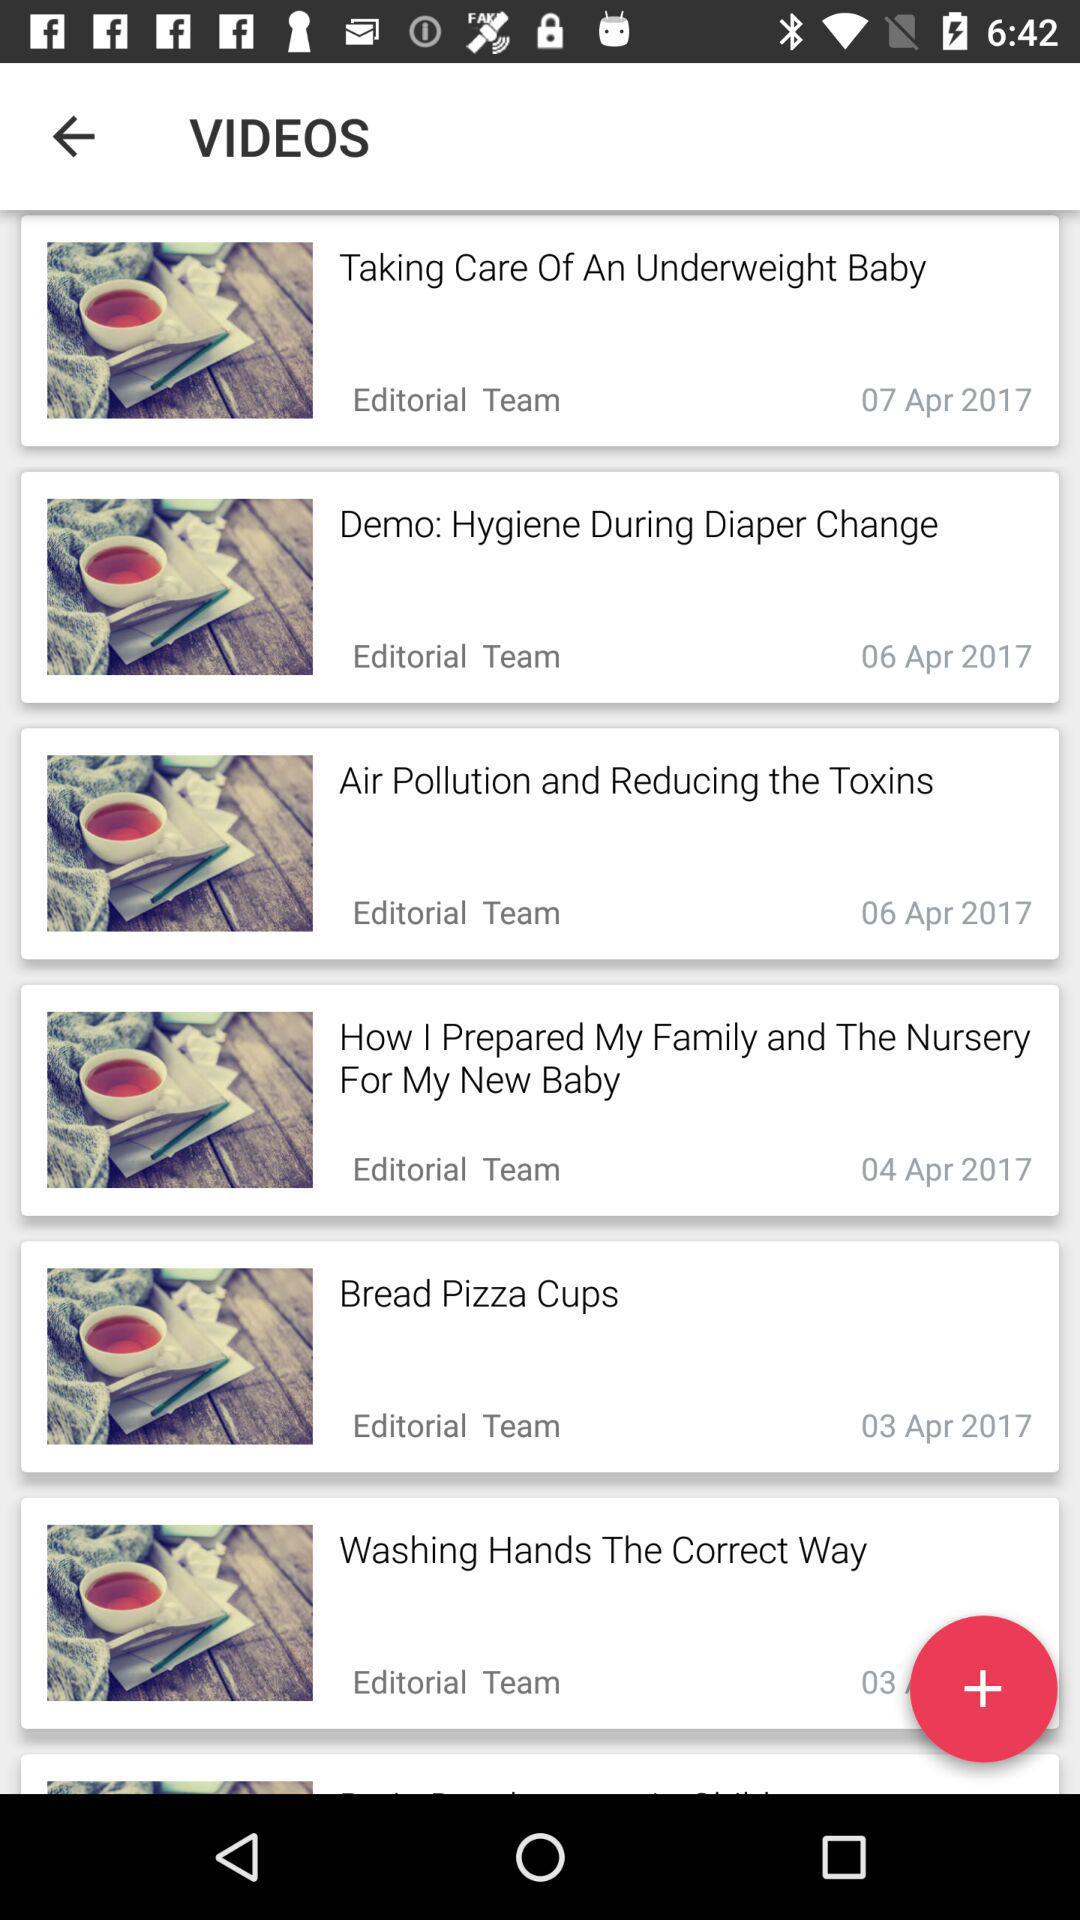Which date was "Washing Hands The Correct Way" posted?
When the provided information is insufficient, respond with <no answer>. <no answer> 